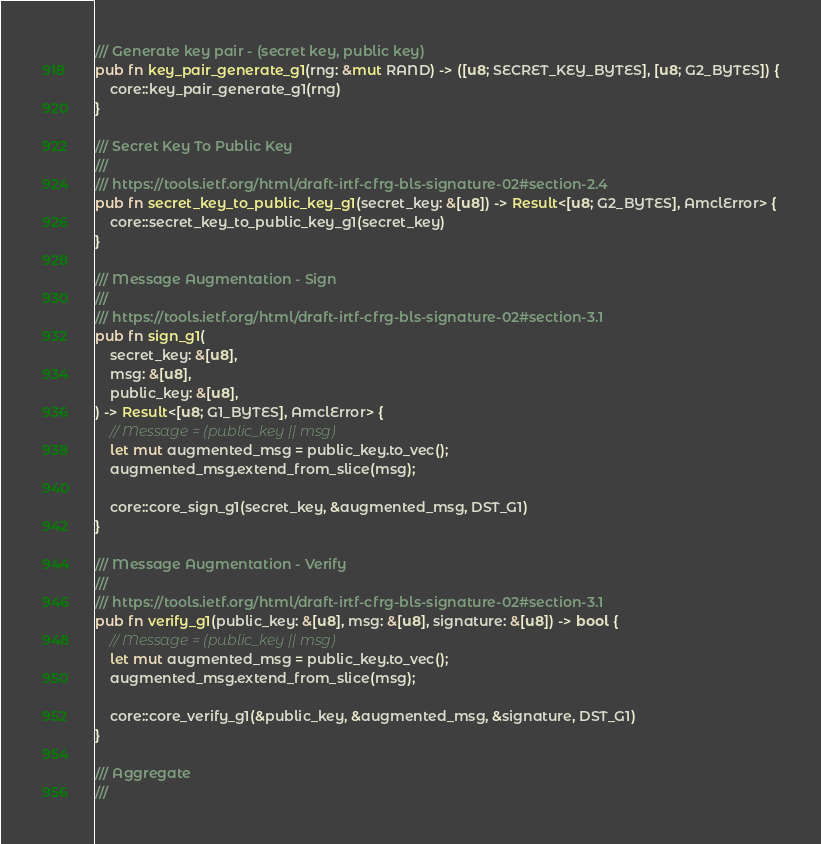<code> <loc_0><loc_0><loc_500><loc_500><_Rust_>/// Generate key pair - (secret key, public key)
pub fn key_pair_generate_g1(rng: &mut RAND) -> ([u8; SECRET_KEY_BYTES], [u8; G2_BYTES]) {
    core::key_pair_generate_g1(rng)
}

/// Secret Key To Public Key
///
/// https://tools.ietf.org/html/draft-irtf-cfrg-bls-signature-02#section-2.4
pub fn secret_key_to_public_key_g1(secret_key: &[u8]) -> Result<[u8; G2_BYTES], AmclError> {
    core::secret_key_to_public_key_g1(secret_key)
}

/// Message Augmentation - Sign
///
/// https://tools.ietf.org/html/draft-irtf-cfrg-bls-signature-02#section-3.1
pub fn sign_g1(
    secret_key: &[u8],
    msg: &[u8],
    public_key: &[u8],
) -> Result<[u8; G1_BYTES], AmclError> {
    // Message = (public_key || msg)
    let mut augmented_msg = public_key.to_vec();
    augmented_msg.extend_from_slice(msg);

    core::core_sign_g1(secret_key, &augmented_msg, DST_G1)
}

/// Message Augmentation - Verify
///
/// https://tools.ietf.org/html/draft-irtf-cfrg-bls-signature-02#section-3.1
pub fn verify_g1(public_key: &[u8], msg: &[u8], signature: &[u8]) -> bool {
    // Message = (public_key || msg)
    let mut augmented_msg = public_key.to_vec();
    augmented_msg.extend_from_slice(msg);

    core::core_verify_g1(&public_key, &augmented_msg, &signature, DST_G1)
}

/// Aggregate
///</code> 